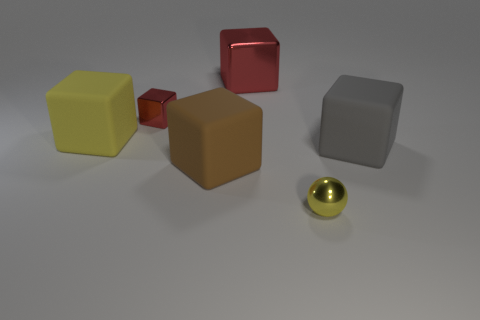What size is the matte object that is the same color as the metallic ball?
Offer a terse response. Large. There is a large brown rubber cube; are there any metallic things to the left of it?
Your answer should be compact. Yes. What is the shape of the brown matte object?
Your answer should be compact. Cube. The tiny thing in front of the large block that is in front of the rubber object on the right side of the big metal cube is what shape?
Ensure brevity in your answer.  Sphere. How many other objects are there of the same shape as the small yellow thing?
Your answer should be very brief. 0. What material is the yellow thing that is in front of the matte thing that is right of the tiny yellow object?
Your response must be concise. Metal. Is the material of the ball the same as the tiny red cube left of the yellow metallic ball?
Keep it short and to the point. Yes. What is the object that is behind the large yellow thing and on the right side of the tiny red shiny thing made of?
Make the answer very short. Metal. The small metal thing that is behind the matte thing that is on the right side of the yellow shiny object is what color?
Keep it short and to the point. Red. There is a small object behind the small yellow metal thing; what is its material?
Offer a very short reply. Metal. 